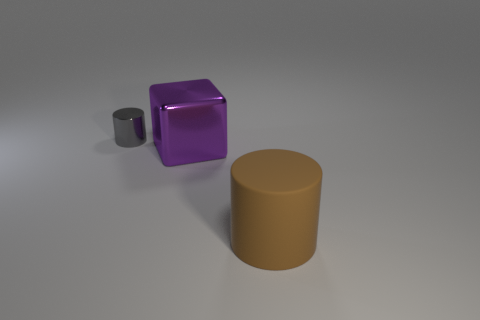Add 2 small blue metal objects. How many objects exist? 5 Subtract all cubes. How many objects are left? 2 Subtract 1 cubes. How many cubes are left? 0 Subtract all cyan cylinders. Subtract all brown cubes. How many cylinders are left? 2 Subtract all blue balls. How many brown cylinders are left? 1 Subtract all brown cylinders. Subtract all brown things. How many objects are left? 1 Add 3 large blocks. How many large blocks are left? 4 Add 2 tiny gray metal objects. How many tiny gray metal objects exist? 3 Subtract 1 gray cylinders. How many objects are left? 2 